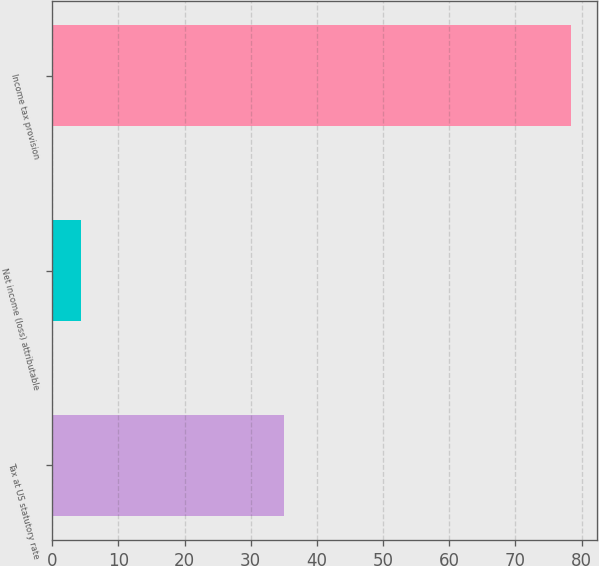Convert chart to OTSL. <chart><loc_0><loc_0><loc_500><loc_500><bar_chart><fcel>Tax at US statutory rate<fcel>Net income (loss) attributable<fcel>Income tax provision<nl><fcel>35<fcel>4.4<fcel>78.4<nl></chart> 